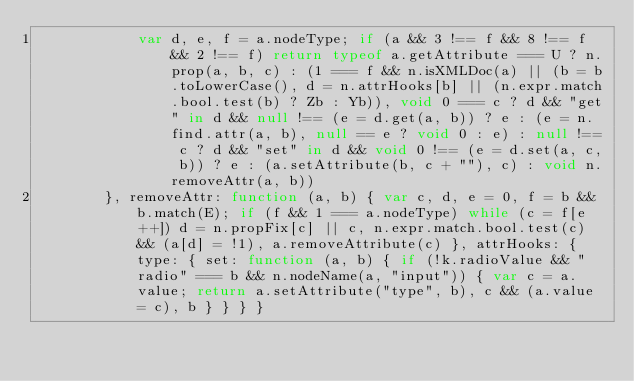Convert code to text. <code><loc_0><loc_0><loc_500><loc_500><_JavaScript_>            var d, e, f = a.nodeType; if (a && 3 !== f && 8 !== f && 2 !== f) return typeof a.getAttribute === U ? n.prop(a, b, c) : (1 === f && n.isXMLDoc(a) || (b = b.toLowerCase(), d = n.attrHooks[b] || (n.expr.match.bool.test(b) ? Zb : Yb)), void 0 === c ? d && "get" in d && null !== (e = d.get(a, b)) ? e : (e = n.find.attr(a, b), null == e ? void 0 : e) : null !== c ? d && "set" in d && void 0 !== (e = d.set(a, c, b)) ? e : (a.setAttribute(b, c + ""), c) : void n.removeAttr(a, b))
        }, removeAttr: function (a, b) { var c, d, e = 0, f = b && b.match(E); if (f && 1 === a.nodeType) while (c = f[e++]) d = n.propFix[c] || c, n.expr.match.bool.test(c) && (a[d] = !1), a.removeAttribute(c) }, attrHooks: { type: { set: function (a, b) { if (!k.radioValue && "radio" === b && n.nodeName(a, "input")) { var c = a.value; return a.setAttribute("type", b), c && (a.value = c), b } } } }</code> 